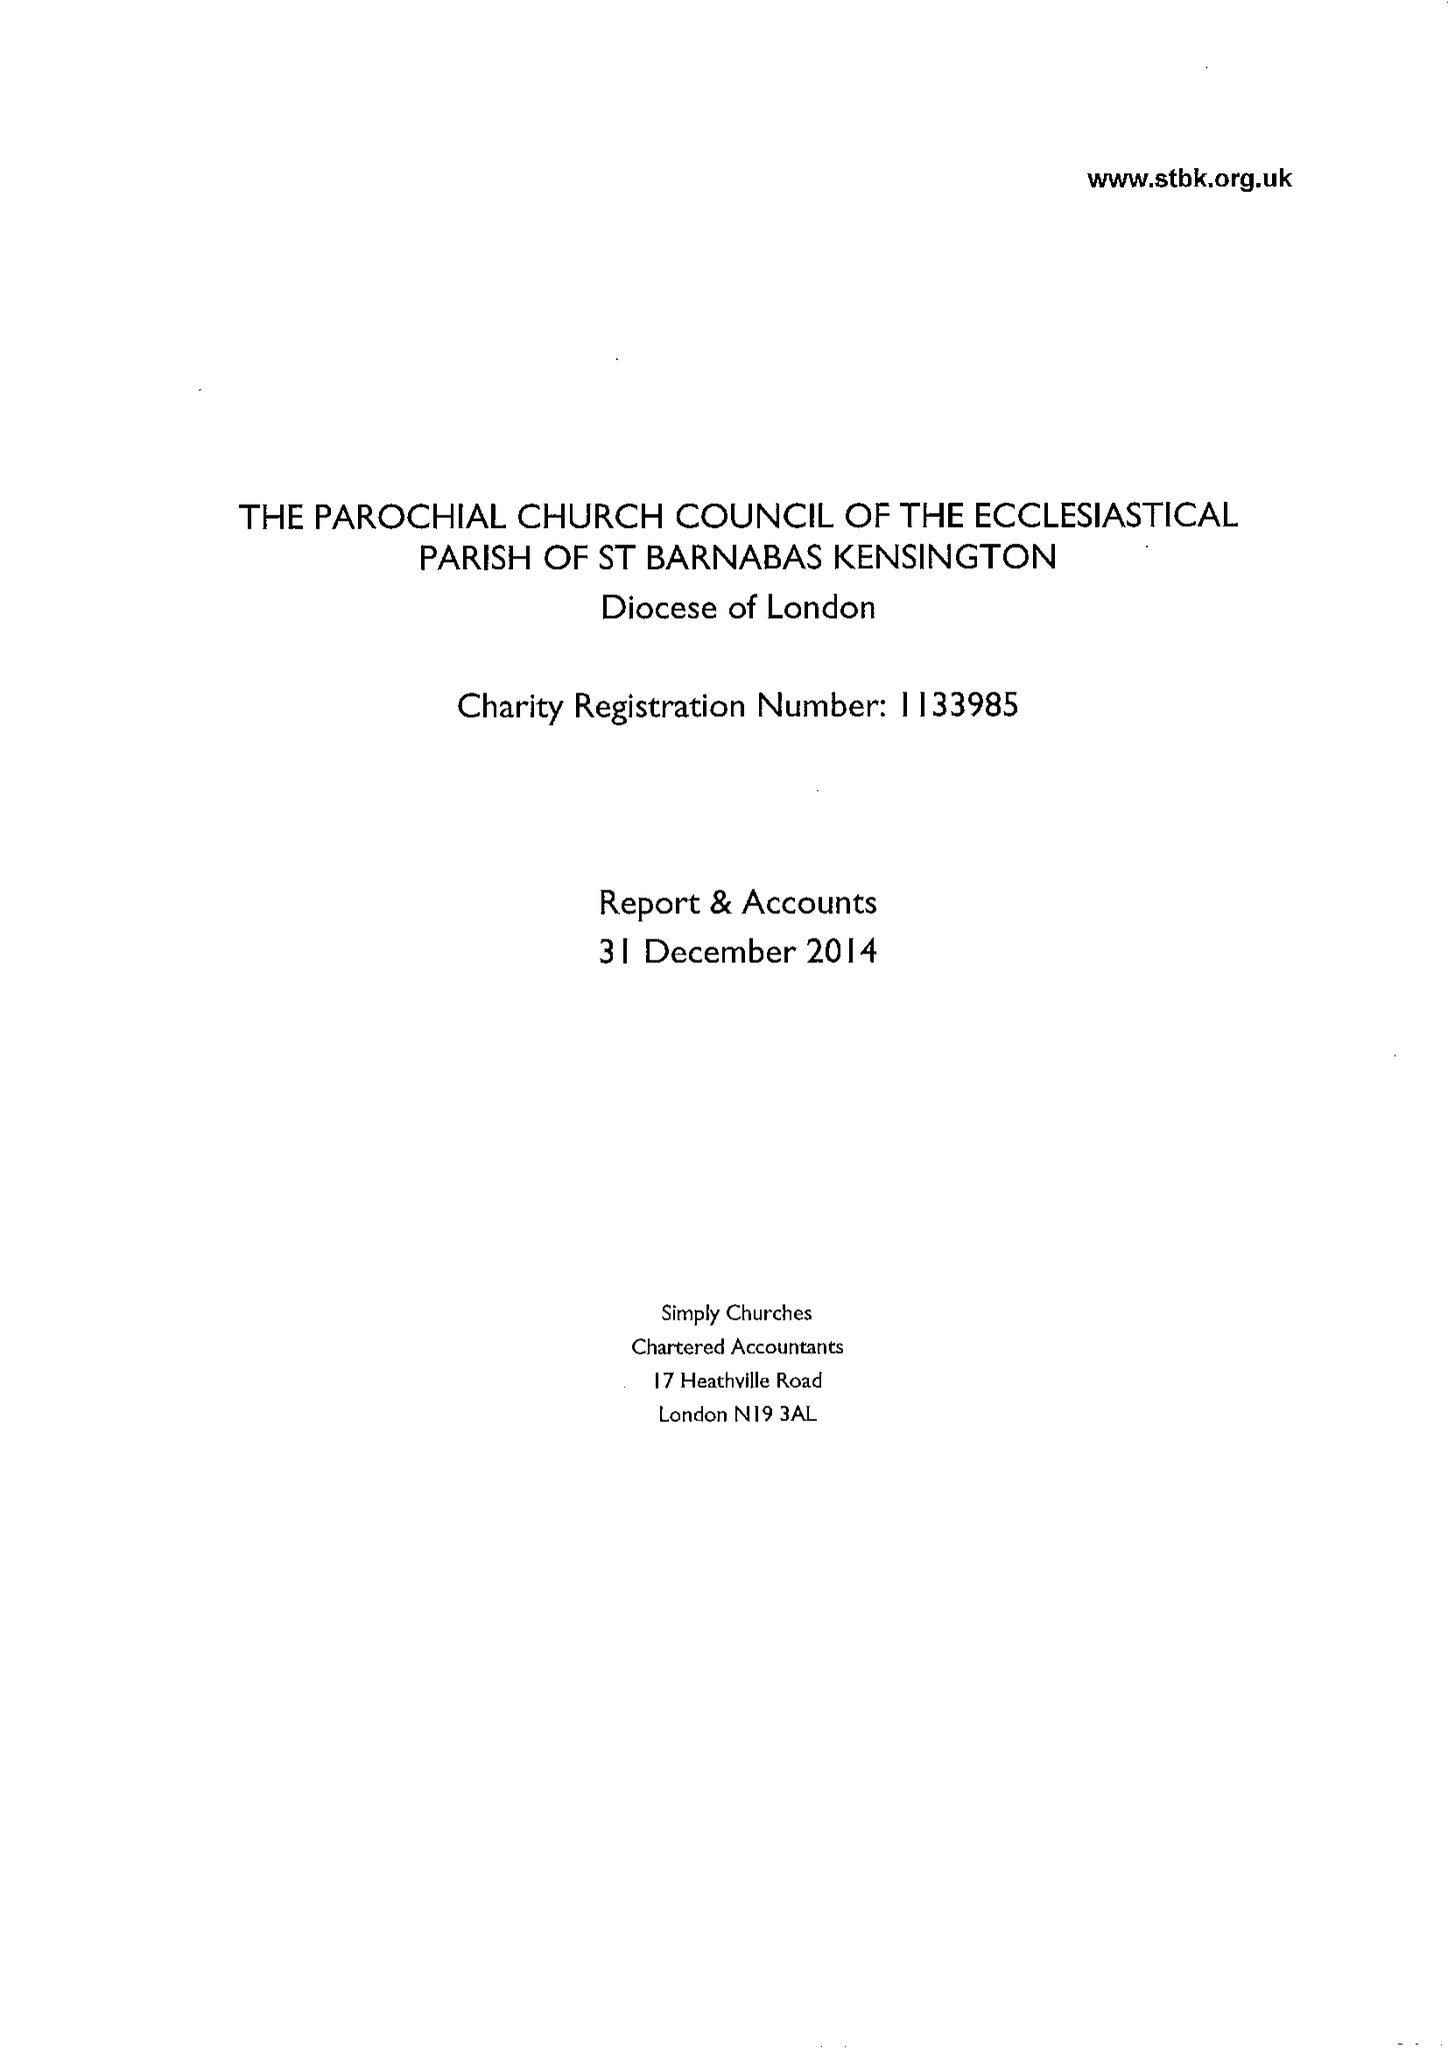What is the value for the address__post_town?
Answer the question using a single word or phrase. LONDON 